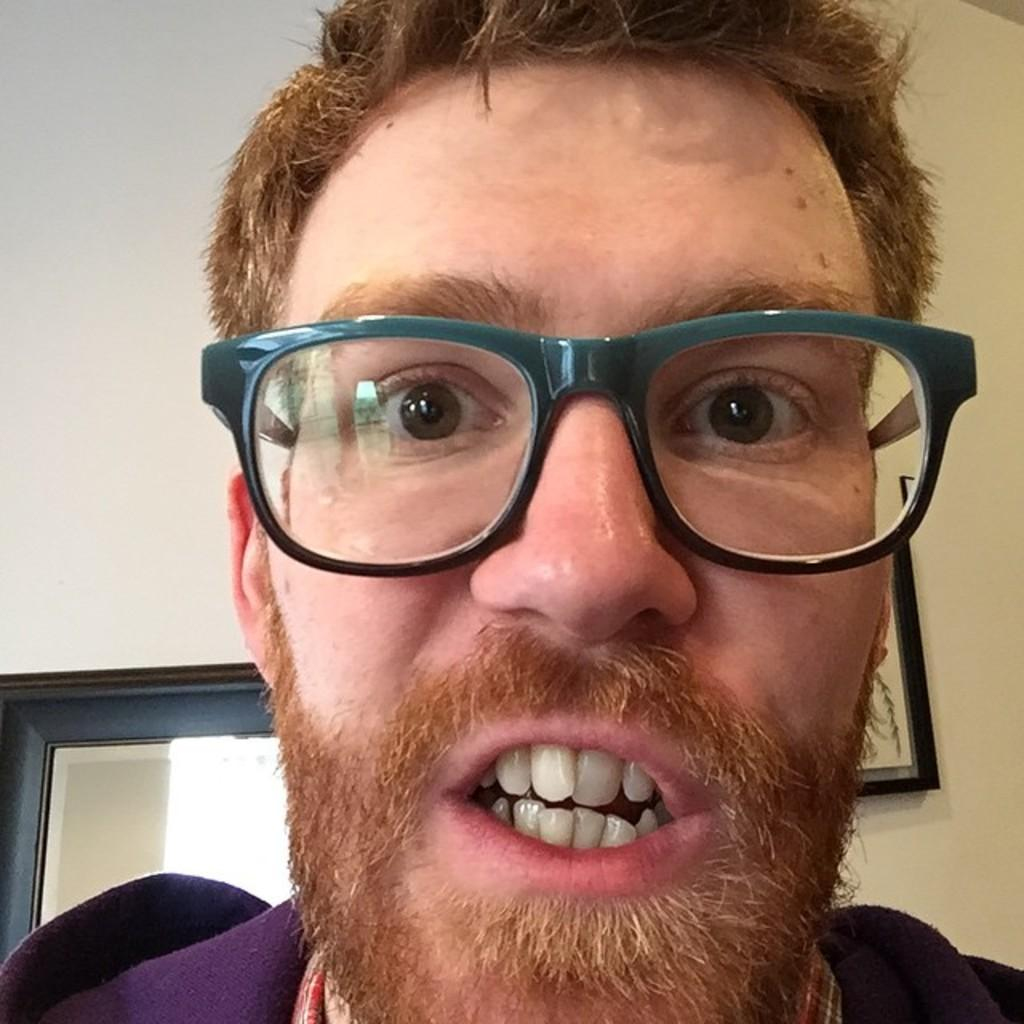Who is present in the image? There is a man in the image. What can be seen on the man's face? The man is wearing spectacles. What is the man wearing on his upper body? The man is wearing a shirt. What can be seen on the wall in the background? There is a photo frame on the wall in the background. Where is the door located in the image? There is a door on the bottom left of the image. What type of disease can be seen on the man's chin in the image? There is no disease visible on the man's chin in the image. 